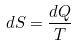<formula> <loc_0><loc_0><loc_500><loc_500>d S = \frac { d Q } { T }</formula> 